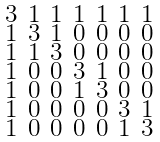Convert formula to latex. <formula><loc_0><loc_0><loc_500><loc_500>\begin{smallmatrix} 3 & 1 & 1 & 1 & 1 & 1 & 1 \\ 1 & 3 & 1 & 0 & 0 & 0 & 0 \\ 1 & 1 & 3 & 0 & 0 & 0 & 0 \\ 1 & 0 & 0 & 3 & 1 & 0 & 0 \\ 1 & 0 & 0 & 1 & 3 & 0 & 0 \\ 1 & 0 & 0 & 0 & 0 & 3 & 1 \\ 1 & 0 & 0 & 0 & 0 & 1 & 3 \end{smallmatrix}</formula> 